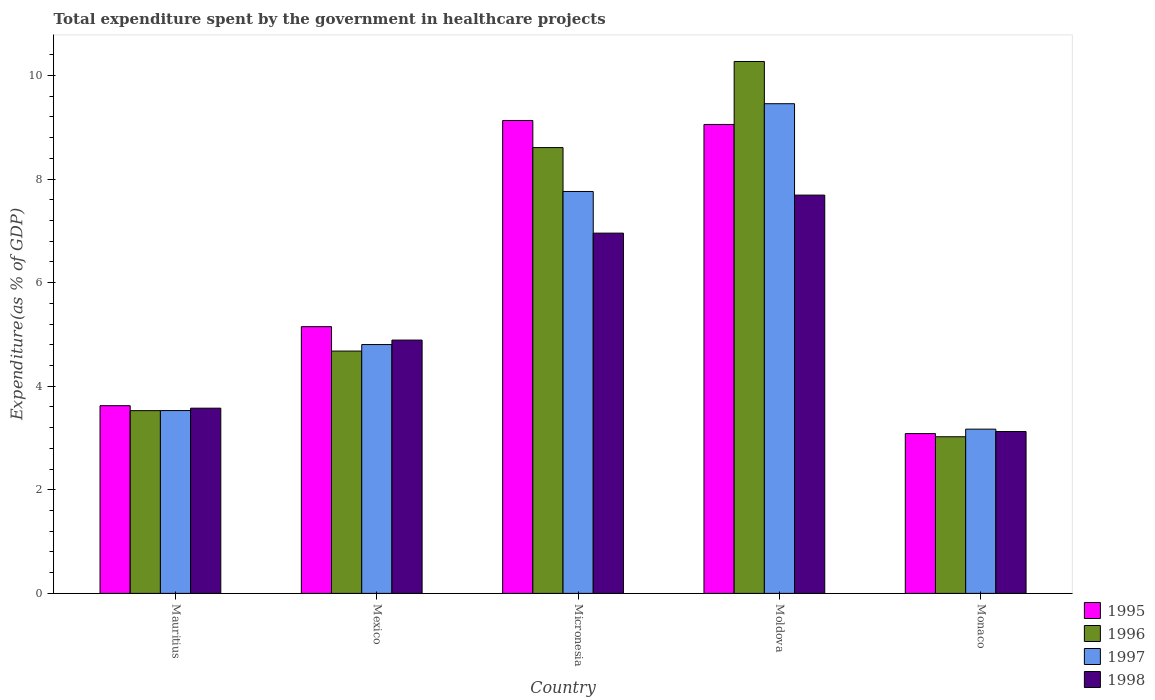Are the number of bars on each tick of the X-axis equal?
Ensure brevity in your answer.  Yes. How many bars are there on the 5th tick from the left?
Offer a very short reply. 4. What is the label of the 4th group of bars from the left?
Keep it short and to the point. Moldova. What is the total expenditure spent by the government in healthcare projects in 1998 in Monaco?
Offer a very short reply. 3.13. Across all countries, what is the maximum total expenditure spent by the government in healthcare projects in 1995?
Offer a very short reply. 9.13. Across all countries, what is the minimum total expenditure spent by the government in healthcare projects in 1995?
Your answer should be compact. 3.09. In which country was the total expenditure spent by the government in healthcare projects in 1998 maximum?
Give a very brief answer. Moldova. In which country was the total expenditure spent by the government in healthcare projects in 1995 minimum?
Ensure brevity in your answer.  Monaco. What is the total total expenditure spent by the government in healthcare projects in 1996 in the graph?
Provide a short and direct response. 30.11. What is the difference between the total expenditure spent by the government in healthcare projects in 1996 in Mauritius and that in Monaco?
Your answer should be very brief. 0.5. What is the difference between the total expenditure spent by the government in healthcare projects in 1998 in Mexico and the total expenditure spent by the government in healthcare projects in 1997 in Monaco?
Offer a very short reply. 1.72. What is the average total expenditure spent by the government in healthcare projects in 1997 per country?
Your response must be concise. 5.74. What is the difference between the total expenditure spent by the government in healthcare projects of/in 1996 and total expenditure spent by the government in healthcare projects of/in 1995 in Moldova?
Offer a terse response. 1.22. In how many countries, is the total expenditure spent by the government in healthcare projects in 1998 greater than 2.4 %?
Your answer should be compact. 5. What is the ratio of the total expenditure spent by the government in healthcare projects in 1998 in Mauritius to that in Monaco?
Provide a succinct answer. 1.14. Is the difference between the total expenditure spent by the government in healthcare projects in 1996 in Micronesia and Monaco greater than the difference between the total expenditure spent by the government in healthcare projects in 1995 in Micronesia and Monaco?
Provide a succinct answer. No. What is the difference between the highest and the second highest total expenditure spent by the government in healthcare projects in 1998?
Your answer should be very brief. -2.06. What is the difference between the highest and the lowest total expenditure spent by the government in healthcare projects in 1997?
Offer a very short reply. 6.28. What does the 1st bar from the left in Micronesia represents?
Keep it short and to the point. 1995. What does the 2nd bar from the right in Mexico represents?
Offer a very short reply. 1997. How many countries are there in the graph?
Offer a very short reply. 5. What is the difference between two consecutive major ticks on the Y-axis?
Provide a short and direct response. 2. Does the graph contain any zero values?
Offer a terse response. No. Where does the legend appear in the graph?
Make the answer very short. Bottom right. How many legend labels are there?
Provide a succinct answer. 4. What is the title of the graph?
Offer a very short reply. Total expenditure spent by the government in healthcare projects. What is the label or title of the Y-axis?
Offer a very short reply. Expenditure(as % of GDP). What is the Expenditure(as % of GDP) of 1995 in Mauritius?
Provide a succinct answer. 3.62. What is the Expenditure(as % of GDP) in 1996 in Mauritius?
Offer a very short reply. 3.53. What is the Expenditure(as % of GDP) in 1997 in Mauritius?
Keep it short and to the point. 3.53. What is the Expenditure(as % of GDP) in 1998 in Mauritius?
Make the answer very short. 3.58. What is the Expenditure(as % of GDP) in 1995 in Mexico?
Your answer should be very brief. 5.15. What is the Expenditure(as % of GDP) in 1996 in Mexico?
Give a very brief answer. 4.68. What is the Expenditure(as % of GDP) of 1997 in Mexico?
Provide a short and direct response. 4.8. What is the Expenditure(as % of GDP) in 1998 in Mexico?
Give a very brief answer. 4.89. What is the Expenditure(as % of GDP) of 1995 in Micronesia?
Offer a terse response. 9.13. What is the Expenditure(as % of GDP) of 1996 in Micronesia?
Offer a very short reply. 8.61. What is the Expenditure(as % of GDP) of 1997 in Micronesia?
Keep it short and to the point. 7.76. What is the Expenditure(as % of GDP) in 1998 in Micronesia?
Keep it short and to the point. 6.96. What is the Expenditure(as % of GDP) in 1995 in Moldova?
Your response must be concise. 9.05. What is the Expenditure(as % of GDP) of 1996 in Moldova?
Your answer should be very brief. 10.27. What is the Expenditure(as % of GDP) of 1997 in Moldova?
Your response must be concise. 9.45. What is the Expenditure(as % of GDP) of 1998 in Moldova?
Your answer should be compact. 7.69. What is the Expenditure(as % of GDP) of 1995 in Monaco?
Provide a short and direct response. 3.09. What is the Expenditure(as % of GDP) in 1996 in Monaco?
Give a very brief answer. 3.02. What is the Expenditure(as % of GDP) in 1997 in Monaco?
Offer a very short reply. 3.17. What is the Expenditure(as % of GDP) of 1998 in Monaco?
Offer a terse response. 3.13. Across all countries, what is the maximum Expenditure(as % of GDP) of 1995?
Provide a short and direct response. 9.13. Across all countries, what is the maximum Expenditure(as % of GDP) in 1996?
Keep it short and to the point. 10.27. Across all countries, what is the maximum Expenditure(as % of GDP) of 1997?
Provide a short and direct response. 9.45. Across all countries, what is the maximum Expenditure(as % of GDP) in 1998?
Provide a short and direct response. 7.69. Across all countries, what is the minimum Expenditure(as % of GDP) in 1995?
Offer a very short reply. 3.09. Across all countries, what is the minimum Expenditure(as % of GDP) in 1996?
Give a very brief answer. 3.02. Across all countries, what is the minimum Expenditure(as % of GDP) in 1997?
Your answer should be compact. 3.17. Across all countries, what is the minimum Expenditure(as % of GDP) in 1998?
Offer a terse response. 3.13. What is the total Expenditure(as % of GDP) in 1995 in the graph?
Make the answer very short. 30.04. What is the total Expenditure(as % of GDP) in 1996 in the graph?
Your answer should be compact. 30.11. What is the total Expenditure(as % of GDP) of 1997 in the graph?
Give a very brief answer. 28.72. What is the total Expenditure(as % of GDP) in 1998 in the graph?
Make the answer very short. 26.24. What is the difference between the Expenditure(as % of GDP) of 1995 in Mauritius and that in Mexico?
Your answer should be very brief. -1.53. What is the difference between the Expenditure(as % of GDP) of 1996 in Mauritius and that in Mexico?
Make the answer very short. -1.15. What is the difference between the Expenditure(as % of GDP) of 1997 in Mauritius and that in Mexico?
Your answer should be compact. -1.27. What is the difference between the Expenditure(as % of GDP) of 1998 in Mauritius and that in Mexico?
Offer a very short reply. -1.31. What is the difference between the Expenditure(as % of GDP) in 1995 in Mauritius and that in Micronesia?
Make the answer very short. -5.51. What is the difference between the Expenditure(as % of GDP) in 1996 in Mauritius and that in Micronesia?
Provide a succinct answer. -5.08. What is the difference between the Expenditure(as % of GDP) in 1997 in Mauritius and that in Micronesia?
Your response must be concise. -4.23. What is the difference between the Expenditure(as % of GDP) in 1998 in Mauritius and that in Micronesia?
Your answer should be very brief. -3.38. What is the difference between the Expenditure(as % of GDP) in 1995 in Mauritius and that in Moldova?
Offer a very short reply. -5.43. What is the difference between the Expenditure(as % of GDP) in 1996 in Mauritius and that in Moldova?
Provide a succinct answer. -6.74. What is the difference between the Expenditure(as % of GDP) of 1997 in Mauritius and that in Moldova?
Your answer should be very brief. -5.92. What is the difference between the Expenditure(as % of GDP) in 1998 in Mauritius and that in Moldova?
Your response must be concise. -4.11. What is the difference between the Expenditure(as % of GDP) of 1995 in Mauritius and that in Monaco?
Keep it short and to the point. 0.54. What is the difference between the Expenditure(as % of GDP) of 1996 in Mauritius and that in Monaco?
Your answer should be compact. 0.5. What is the difference between the Expenditure(as % of GDP) in 1997 in Mauritius and that in Monaco?
Give a very brief answer. 0.36. What is the difference between the Expenditure(as % of GDP) in 1998 in Mauritius and that in Monaco?
Offer a terse response. 0.45. What is the difference between the Expenditure(as % of GDP) in 1995 in Mexico and that in Micronesia?
Offer a terse response. -3.98. What is the difference between the Expenditure(as % of GDP) in 1996 in Mexico and that in Micronesia?
Give a very brief answer. -3.93. What is the difference between the Expenditure(as % of GDP) in 1997 in Mexico and that in Micronesia?
Offer a very short reply. -2.96. What is the difference between the Expenditure(as % of GDP) of 1998 in Mexico and that in Micronesia?
Provide a short and direct response. -2.06. What is the difference between the Expenditure(as % of GDP) of 1995 in Mexico and that in Moldova?
Make the answer very short. -3.9. What is the difference between the Expenditure(as % of GDP) in 1996 in Mexico and that in Moldova?
Provide a short and direct response. -5.59. What is the difference between the Expenditure(as % of GDP) of 1997 in Mexico and that in Moldova?
Your answer should be compact. -4.65. What is the difference between the Expenditure(as % of GDP) of 1998 in Mexico and that in Moldova?
Your answer should be compact. -2.8. What is the difference between the Expenditure(as % of GDP) in 1995 in Mexico and that in Monaco?
Make the answer very short. 2.06. What is the difference between the Expenditure(as % of GDP) in 1996 in Mexico and that in Monaco?
Provide a succinct answer. 1.65. What is the difference between the Expenditure(as % of GDP) in 1997 in Mexico and that in Monaco?
Provide a succinct answer. 1.63. What is the difference between the Expenditure(as % of GDP) in 1998 in Mexico and that in Monaco?
Ensure brevity in your answer.  1.77. What is the difference between the Expenditure(as % of GDP) of 1995 in Micronesia and that in Moldova?
Offer a very short reply. 0.08. What is the difference between the Expenditure(as % of GDP) of 1996 in Micronesia and that in Moldova?
Provide a short and direct response. -1.66. What is the difference between the Expenditure(as % of GDP) in 1997 in Micronesia and that in Moldova?
Offer a terse response. -1.69. What is the difference between the Expenditure(as % of GDP) in 1998 in Micronesia and that in Moldova?
Provide a succinct answer. -0.73. What is the difference between the Expenditure(as % of GDP) of 1995 in Micronesia and that in Monaco?
Give a very brief answer. 6.04. What is the difference between the Expenditure(as % of GDP) in 1996 in Micronesia and that in Monaco?
Keep it short and to the point. 5.58. What is the difference between the Expenditure(as % of GDP) in 1997 in Micronesia and that in Monaco?
Offer a very short reply. 4.59. What is the difference between the Expenditure(as % of GDP) in 1998 in Micronesia and that in Monaco?
Offer a terse response. 3.83. What is the difference between the Expenditure(as % of GDP) in 1995 in Moldova and that in Monaco?
Your answer should be compact. 5.97. What is the difference between the Expenditure(as % of GDP) in 1996 in Moldova and that in Monaco?
Make the answer very short. 7.25. What is the difference between the Expenditure(as % of GDP) in 1997 in Moldova and that in Monaco?
Your answer should be very brief. 6.28. What is the difference between the Expenditure(as % of GDP) of 1998 in Moldova and that in Monaco?
Keep it short and to the point. 4.56. What is the difference between the Expenditure(as % of GDP) in 1995 in Mauritius and the Expenditure(as % of GDP) in 1996 in Mexico?
Offer a very short reply. -1.05. What is the difference between the Expenditure(as % of GDP) in 1995 in Mauritius and the Expenditure(as % of GDP) in 1997 in Mexico?
Give a very brief answer. -1.18. What is the difference between the Expenditure(as % of GDP) of 1995 in Mauritius and the Expenditure(as % of GDP) of 1998 in Mexico?
Give a very brief answer. -1.27. What is the difference between the Expenditure(as % of GDP) in 1996 in Mauritius and the Expenditure(as % of GDP) in 1997 in Mexico?
Make the answer very short. -1.28. What is the difference between the Expenditure(as % of GDP) in 1996 in Mauritius and the Expenditure(as % of GDP) in 1998 in Mexico?
Offer a terse response. -1.36. What is the difference between the Expenditure(as % of GDP) of 1997 in Mauritius and the Expenditure(as % of GDP) of 1998 in Mexico?
Your answer should be compact. -1.36. What is the difference between the Expenditure(as % of GDP) in 1995 in Mauritius and the Expenditure(as % of GDP) in 1996 in Micronesia?
Ensure brevity in your answer.  -4.98. What is the difference between the Expenditure(as % of GDP) in 1995 in Mauritius and the Expenditure(as % of GDP) in 1997 in Micronesia?
Ensure brevity in your answer.  -4.14. What is the difference between the Expenditure(as % of GDP) of 1995 in Mauritius and the Expenditure(as % of GDP) of 1998 in Micronesia?
Make the answer very short. -3.33. What is the difference between the Expenditure(as % of GDP) in 1996 in Mauritius and the Expenditure(as % of GDP) in 1997 in Micronesia?
Your response must be concise. -4.23. What is the difference between the Expenditure(as % of GDP) of 1996 in Mauritius and the Expenditure(as % of GDP) of 1998 in Micronesia?
Provide a succinct answer. -3.43. What is the difference between the Expenditure(as % of GDP) of 1997 in Mauritius and the Expenditure(as % of GDP) of 1998 in Micronesia?
Keep it short and to the point. -3.43. What is the difference between the Expenditure(as % of GDP) in 1995 in Mauritius and the Expenditure(as % of GDP) in 1996 in Moldova?
Keep it short and to the point. -6.65. What is the difference between the Expenditure(as % of GDP) in 1995 in Mauritius and the Expenditure(as % of GDP) in 1997 in Moldova?
Make the answer very short. -5.83. What is the difference between the Expenditure(as % of GDP) of 1995 in Mauritius and the Expenditure(as % of GDP) of 1998 in Moldova?
Your answer should be very brief. -4.07. What is the difference between the Expenditure(as % of GDP) in 1996 in Mauritius and the Expenditure(as % of GDP) in 1997 in Moldova?
Your answer should be very brief. -5.93. What is the difference between the Expenditure(as % of GDP) of 1996 in Mauritius and the Expenditure(as % of GDP) of 1998 in Moldova?
Your response must be concise. -4.16. What is the difference between the Expenditure(as % of GDP) of 1997 in Mauritius and the Expenditure(as % of GDP) of 1998 in Moldova?
Give a very brief answer. -4.16. What is the difference between the Expenditure(as % of GDP) in 1995 in Mauritius and the Expenditure(as % of GDP) in 1996 in Monaco?
Ensure brevity in your answer.  0.6. What is the difference between the Expenditure(as % of GDP) of 1995 in Mauritius and the Expenditure(as % of GDP) of 1997 in Monaco?
Your answer should be compact. 0.45. What is the difference between the Expenditure(as % of GDP) of 1995 in Mauritius and the Expenditure(as % of GDP) of 1998 in Monaco?
Your answer should be compact. 0.5. What is the difference between the Expenditure(as % of GDP) in 1996 in Mauritius and the Expenditure(as % of GDP) in 1997 in Monaco?
Your response must be concise. 0.36. What is the difference between the Expenditure(as % of GDP) of 1996 in Mauritius and the Expenditure(as % of GDP) of 1998 in Monaco?
Provide a succinct answer. 0.4. What is the difference between the Expenditure(as % of GDP) of 1997 in Mauritius and the Expenditure(as % of GDP) of 1998 in Monaco?
Provide a short and direct response. 0.4. What is the difference between the Expenditure(as % of GDP) in 1995 in Mexico and the Expenditure(as % of GDP) in 1996 in Micronesia?
Ensure brevity in your answer.  -3.46. What is the difference between the Expenditure(as % of GDP) in 1995 in Mexico and the Expenditure(as % of GDP) in 1997 in Micronesia?
Ensure brevity in your answer.  -2.61. What is the difference between the Expenditure(as % of GDP) of 1995 in Mexico and the Expenditure(as % of GDP) of 1998 in Micronesia?
Your answer should be compact. -1.81. What is the difference between the Expenditure(as % of GDP) in 1996 in Mexico and the Expenditure(as % of GDP) in 1997 in Micronesia?
Your answer should be very brief. -3.08. What is the difference between the Expenditure(as % of GDP) of 1996 in Mexico and the Expenditure(as % of GDP) of 1998 in Micronesia?
Offer a very short reply. -2.28. What is the difference between the Expenditure(as % of GDP) of 1997 in Mexico and the Expenditure(as % of GDP) of 1998 in Micronesia?
Your response must be concise. -2.15. What is the difference between the Expenditure(as % of GDP) in 1995 in Mexico and the Expenditure(as % of GDP) in 1996 in Moldova?
Make the answer very short. -5.12. What is the difference between the Expenditure(as % of GDP) of 1995 in Mexico and the Expenditure(as % of GDP) of 1997 in Moldova?
Offer a very short reply. -4.3. What is the difference between the Expenditure(as % of GDP) of 1995 in Mexico and the Expenditure(as % of GDP) of 1998 in Moldova?
Your answer should be compact. -2.54. What is the difference between the Expenditure(as % of GDP) of 1996 in Mexico and the Expenditure(as % of GDP) of 1997 in Moldova?
Give a very brief answer. -4.78. What is the difference between the Expenditure(as % of GDP) in 1996 in Mexico and the Expenditure(as % of GDP) in 1998 in Moldova?
Keep it short and to the point. -3.01. What is the difference between the Expenditure(as % of GDP) of 1997 in Mexico and the Expenditure(as % of GDP) of 1998 in Moldova?
Your answer should be compact. -2.89. What is the difference between the Expenditure(as % of GDP) in 1995 in Mexico and the Expenditure(as % of GDP) in 1996 in Monaco?
Give a very brief answer. 2.13. What is the difference between the Expenditure(as % of GDP) of 1995 in Mexico and the Expenditure(as % of GDP) of 1997 in Monaco?
Your response must be concise. 1.98. What is the difference between the Expenditure(as % of GDP) in 1995 in Mexico and the Expenditure(as % of GDP) in 1998 in Monaco?
Your answer should be compact. 2.02. What is the difference between the Expenditure(as % of GDP) of 1996 in Mexico and the Expenditure(as % of GDP) of 1997 in Monaco?
Make the answer very short. 1.51. What is the difference between the Expenditure(as % of GDP) of 1996 in Mexico and the Expenditure(as % of GDP) of 1998 in Monaco?
Make the answer very short. 1.55. What is the difference between the Expenditure(as % of GDP) in 1997 in Mexico and the Expenditure(as % of GDP) in 1998 in Monaco?
Your answer should be very brief. 1.68. What is the difference between the Expenditure(as % of GDP) of 1995 in Micronesia and the Expenditure(as % of GDP) of 1996 in Moldova?
Make the answer very short. -1.14. What is the difference between the Expenditure(as % of GDP) of 1995 in Micronesia and the Expenditure(as % of GDP) of 1997 in Moldova?
Make the answer very short. -0.32. What is the difference between the Expenditure(as % of GDP) in 1995 in Micronesia and the Expenditure(as % of GDP) in 1998 in Moldova?
Offer a very short reply. 1.44. What is the difference between the Expenditure(as % of GDP) of 1996 in Micronesia and the Expenditure(as % of GDP) of 1997 in Moldova?
Your answer should be compact. -0.85. What is the difference between the Expenditure(as % of GDP) of 1996 in Micronesia and the Expenditure(as % of GDP) of 1998 in Moldova?
Provide a short and direct response. 0.92. What is the difference between the Expenditure(as % of GDP) of 1997 in Micronesia and the Expenditure(as % of GDP) of 1998 in Moldova?
Provide a short and direct response. 0.07. What is the difference between the Expenditure(as % of GDP) in 1995 in Micronesia and the Expenditure(as % of GDP) in 1996 in Monaco?
Your answer should be compact. 6.11. What is the difference between the Expenditure(as % of GDP) of 1995 in Micronesia and the Expenditure(as % of GDP) of 1997 in Monaco?
Provide a short and direct response. 5.96. What is the difference between the Expenditure(as % of GDP) of 1995 in Micronesia and the Expenditure(as % of GDP) of 1998 in Monaco?
Ensure brevity in your answer.  6. What is the difference between the Expenditure(as % of GDP) in 1996 in Micronesia and the Expenditure(as % of GDP) in 1997 in Monaco?
Your answer should be very brief. 5.44. What is the difference between the Expenditure(as % of GDP) in 1996 in Micronesia and the Expenditure(as % of GDP) in 1998 in Monaco?
Provide a short and direct response. 5.48. What is the difference between the Expenditure(as % of GDP) of 1997 in Micronesia and the Expenditure(as % of GDP) of 1998 in Monaco?
Make the answer very short. 4.63. What is the difference between the Expenditure(as % of GDP) in 1995 in Moldova and the Expenditure(as % of GDP) in 1996 in Monaco?
Offer a terse response. 6.03. What is the difference between the Expenditure(as % of GDP) in 1995 in Moldova and the Expenditure(as % of GDP) in 1997 in Monaco?
Your answer should be very brief. 5.88. What is the difference between the Expenditure(as % of GDP) of 1995 in Moldova and the Expenditure(as % of GDP) of 1998 in Monaco?
Your answer should be very brief. 5.93. What is the difference between the Expenditure(as % of GDP) of 1996 in Moldova and the Expenditure(as % of GDP) of 1997 in Monaco?
Provide a succinct answer. 7.1. What is the difference between the Expenditure(as % of GDP) of 1996 in Moldova and the Expenditure(as % of GDP) of 1998 in Monaco?
Offer a terse response. 7.14. What is the difference between the Expenditure(as % of GDP) of 1997 in Moldova and the Expenditure(as % of GDP) of 1998 in Monaco?
Your answer should be compact. 6.33. What is the average Expenditure(as % of GDP) in 1995 per country?
Provide a short and direct response. 6.01. What is the average Expenditure(as % of GDP) of 1996 per country?
Your answer should be compact. 6.02. What is the average Expenditure(as % of GDP) of 1997 per country?
Give a very brief answer. 5.74. What is the average Expenditure(as % of GDP) in 1998 per country?
Ensure brevity in your answer.  5.25. What is the difference between the Expenditure(as % of GDP) of 1995 and Expenditure(as % of GDP) of 1996 in Mauritius?
Ensure brevity in your answer.  0.1. What is the difference between the Expenditure(as % of GDP) in 1995 and Expenditure(as % of GDP) in 1997 in Mauritius?
Give a very brief answer. 0.09. What is the difference between the Expenditure(as % of GDP) of 1995 and Expenditure(as % of GDP) of 1998 in Mauritius?
Your answer should be very brief. 0.05. What is the difference between the Expenditure(as % of GDP) of 1996 and Expenditure(as % of GDP) of 1997 in Mauritius?
Your response must be concise. -0. What is the difference between the Expenditure(as % of GDP) in 1996 and Expenditure(as % of GDP) in 1998 in Mauritius?
Offer a very short reply. -0.05. What is the difference between the Expenditure(as % of GDP) in 1997 and Expenditure(as % of GDP) in 1998 in Mauritius?
Make the answer very short. -0.05. What is the difference between the Expenditure(as % of GDP) of 1995 and Expenditure(as % of GDP) of 1996 in Mexico?
Your answer should be very brief. 0.47. What is the difference between the Expenditure(as % of GDP) of 1995 and Expenditure(as % of GDP) of 1997 in Mexico?
Provide a succinct answer. 0.35. What is the difference between the Expenditure(as % of GDP) of 1995 and Expenditure(as % of GDP) of 1998 in Mexico?
Keep it short and to the point. 0.26. What is the difference between the Expenditure(as % of GDP) of 1996 and Expenditure(as % of GDP) of 1997 in Mexico?
Offer a very short reply. -0.13. What is the difference between the Expenditure(as % of GDP) of 1996 and Expenditure(as % of GDP) of 1998 in Mexico?
Ensure brevity in your answer.  -0.21. What is the difference between the Expenditure(as % of GDP) of 1997 and Expenditure(as % of GDP) of 1998 in Mexico?
Offer a very short reply. -0.09. What is the difference between the Expenditure(as % of GDP) in 1995 and Expenditure(as % of GDP) in 1996 in Micronesia?
Your response must be concise. 0.52. What is the difference between the Expenditure(as % of GDP) in 1995 and Expenditure(as % of GDP) in 1997 in Micronesia?
Your answer should be very brief. 1.37. What is the difference between the Expenditure(as % of GDP) of 1995 and Expenditure(as % of GDP) of 1998 in Micronesia?
Make the answer very short. 2.18. What is the difference between the Expenditure(as % of GDP) in 1996 and Expenditure(as % of GDP) in 1997 in Micronesia?
Give a very brief answer. 0.85. What is the difference between the Expenditure(as % of GDP) in 1996 and Expenditure(as % of GDP) in 1998 in Micronesia?
Offer a terse response. 1.65. What is the difference between the Expenditure(as % of GDP) of 1997 and Expenditure(as % of GDP) of 1998 in Micronesia?
Ensure brevity in your answer.  0.8. What is the difference between the Expenditure(as % of GDP) in 1995 and Expenditure(as % of GDP) in 1996 in Moldova?
Ensure brevity in your answer.  -1.22. What is the difference between the Expenditure(as % of GDP) of 1995 and Expenditure(as % of GDP) of 1997 in Moldova?
Ensure brevity in your answer.  -0.4. What is the difference between the Expenditure(as % of GDP) in 1995 and Expenditure(as % of GDP) in 1998 in Moldova?
Give a very brief answer. 1.36. What is the difference between the Expenditure(as % of GDP) of 1996 and Expenditure(as % of GDP) of 1997 in Moldova?
Your answer should be very brief. 0.82. What is the difference between the Expenditure(as % of GDP) of 1996 and Expenditure(as % of GDP) of 1998 in Moldova?
Give a very brief answer. 2.58. What is the difference between the Expenditure(as % of GDP) in 1997 and Expenditure(as % of GDP) in 1998 in Moldova?
Give a very brief answer. 1.76. What is the difference between the Expenditure(as % of GDP) in 1995 and Expenditure(as % of GDP) in 1996 in Monaco?
Your response must be concise. 0.06. What is the difference between the Expenditure(as % of GDP) in 1995 and Expenditure(as % of GDP) in 1997 in Monaco?
Provide a short and direct response. -0.09. What is the difference between the Expenditure(as % of GDP) of 1995 and Expenditure(as % of GDP) of 1998 in Monaco?
Offer a very short reply. -0.04. What is the difference between the Expenditure(as % of GDP) of 1996 and Expenditure(as % of GDP) of 1997 in Monaco?
Your response must be concise. -0.15. What is the difference between the Expenditure(as % of GDP) of 1996 and Expenditure(as % of GDP) of 1998 in Monaco?
Offer a very short reply. -0.1. What is the difference between the Expenditure(as % of GDP) of 1997 and Expenditure(as % of GDP) of 1998 in Monaco?
Your answer should be very brief. 0.05. What is the ratio of the Expenditure(as % of GDP) in 1995 in Mauritius to that in Mexico?
Your response must be concise. 0.7. What is the ratio of the Expenditure(as % of GDP) of 1996 in Mauritius to that in Mexico?
Provide a short and direct response. 0.75. What is the ratio of the Expenditure(as % of GDP) of 1997 in Mauritius to that in Mexico?
Keep it short and to the point. 0.73. What is the ratio of the Expenditure(as % of GDP) in 1998 in Mauritius to that in Mexico?
Keep it short and to the point. 0.73. What is the ratio of the Expenditure(as % of GDP) in 1995 in Mauritius to that in Micronesia?
Keep it short and to the point. 0.4. What is the ratio of the Expenditure(as % of GDP) in 1996 in Mauritius to that in Micronesia?
Ensure brevity in your answer.  0.41. What is the ratio of the Expenditure(as % of GDP) of 1997 in Mauritius to that in Micronesia?
Offer a terse response. 0.45. What is the ratio of the Expenditure(as % of GDP) of 1998 in Mauritius to that in Micronesia?
Your answer should be compact. 0.51. What is the ratio of the Expenditure(as % of GDP) of 1995 in Mauritius to that in Moldova?
Provide a short and direct response. 0.4. What is the ratio of the Expenditure(as % of GDP) of 1996 in Mauritius to that in Moldova?
Provide a short and direct response. 0.34. What is the ratio of the Expenditure(as % of GDP) of 1997 in Mauritius to that in Moldova?
Provide a short and direct response. 0.37. What is the ratio of the Expenditure(as % of GDP) of 1998 in Mauritius to that in Moldova?
Make the answer very short. 0.47. What is the ratio of the Expenditure(as % of GDP) in 1995 in Mauritius to that in Monaco?
Provide a short and direct response. 1.17. What is the ratio of the Expenditure(as % of GDP) in 1996 in Mauritius to that in Monaco?
Provide a succinct answer. 1.17. What is the ratio of the Expenditure(as % of GDP) in 1997 in Mauritius to that in Monaco?
Your response must be concise. 1.11. What is the ratio of the Expenditure(as % of GDP) in 1998 in Mauritius to that in Monaco?
Provide a short and direct response. 1.14. What is the ratio of the Expenditure(as % of GDP) of 1995 in Mexico to that in Micronesia?
Keep it short and to the point. 0.56. What is the ratio of the Expenditure(as % of GDP) of 1996 in Mexico to that in Micronesia?
Your response must be concise. 0.54. What is the ratio of the Expenditure(as % of GDP) of 1997 in Mexico to that in Micronesia?
Ensure brevity in your answer.  0.62. What is the ratio of the Expenditure(as % of GDP) of 1998 in Mexico to that in Micronesia?
Your response must be concise. 0.7. What is the ratio of the Expenditure(as % of GDP) of 1995 in Mexico to that in Moldova?
Your answer should be compact. 0.57. What is the ratio of the Expenditure(as % of GDP) in 1996 in Mexico to that in Moldova?
Give a very brief answer. 0.46. What is the ratio of the Expenditure(as % of GDP) of 1997 in Mexico to that in Moldova?
Ensure brevity in your answer.  0.51. What is the ratio of the Expenditure(as % of GDP) in 1998 in Mexico to that in Moldova?
Your answer should be compact. 0.64. What is the ratio of the Expenditure(as % of GDP) of 1995 in Mexico to that in Monaco?
Your response must be concise. 1.67. What is the ratio of the Expenditure(as % of GDP) in 1996 in Mexico to that in Monaco?
Offer a terse response. 1.55. What is the ratio of the Expenditure(as % of GDP) in 1997 in Mexico to that in Monaco?
Ensure brevity in your answer.  1.52. What is the ratio of the Expenditure(as % of GDP) in 1998 in Mexico to that in Monaco?
Provide a succinct answer. 1.56. What is the ratio of the Expenditure(as % of GDP) in 1995 in Micronesia to that in Moldova?
Ensure brevity in your answer.  1.01. What is the ratio of the Expenditure(as % of GDP) in 1996 in Micronesia to that in Moldova?
Your answer should be compact. 0.84. What is the ratio of the Expenditure(as % of GDP) in 1997 in Micronesia to that in Moldova?
Your answer should be very brief. 0.82. What is the ratio of the Expenditure(as % of GDP) of 1998 in Micronesia to that in Moldova?
Provide a short and direct response. 0.9. What is the ratio of the Expenditure(as % of GDP) of 1995 in Micronesia to that in Monaco?
Ensure brevity in your answer.  2.96. What is the ratio of the Expenditure(as % of GDP) of 1996 in Micronesia to that in Monaco?
Offer a terse response. 2.85. What is the ratio of the Expenditure(as % of GDP) in 1997 in Micronesia to that in Monaco?
Give a very brief answer. 2.45. What is the ratio of the Expenditure(as % of GDP) of 1998 in Micronesia to that in Monaco?
Your answer should be compact. 2.23. What is the ratio of the Expenditure(as % of GDP) in 1995 in Moldova to that in Monaco?
Provide a succinct answer. 2.93. What is the ratio of the Expenditure(as % of GDP) in 1996 in Moldova to that in Monaco?
Make the answer very short. 3.4. What is the ratio of the Expenditure(as % of GDP) in 1997 in Moldova to that in Monaco?
Make the answer very short. 2.98. What is the ratio of the Expenditure(as % of GDP) in 1998 in Moldova to that in Monaco?
Offer a terse response. 2.46. What is the difference between the highest and the second highest Expenditure(as % of GDP) in 1995?
Ensure brevity in your answer.  0.08. What is the difference between the highest and the second highest Expenditure(as % of GDP) in 1996?
Your response must be concise. 1.66. What is the difference between the highest and the second highest Expenditure(as % of GDP) in 1997?
Your response must be concise. 1.69. What is the difference between the highest and the second highest Expenditure(as % of GDP) in 1998?
Your answer should be compact. 0.73. What is the difference between the highest and the lowest Expenditure(as % of GDP) in 1995?
Ensure brevity in your answer.  6.04. What is the difference between the highest and the lowest Expenditure(as % of GDP) of 1996?
Provide a short and direct response. 7.25. What is the difference between the highest and the lowest Expenditure(as % of GDP) of 1997?
Your answer should be compact. 6.28. What is the difference between the highest and the lowest Expenditure(as % of GDP) in 1998?
Your response must be concise. 4.56. 